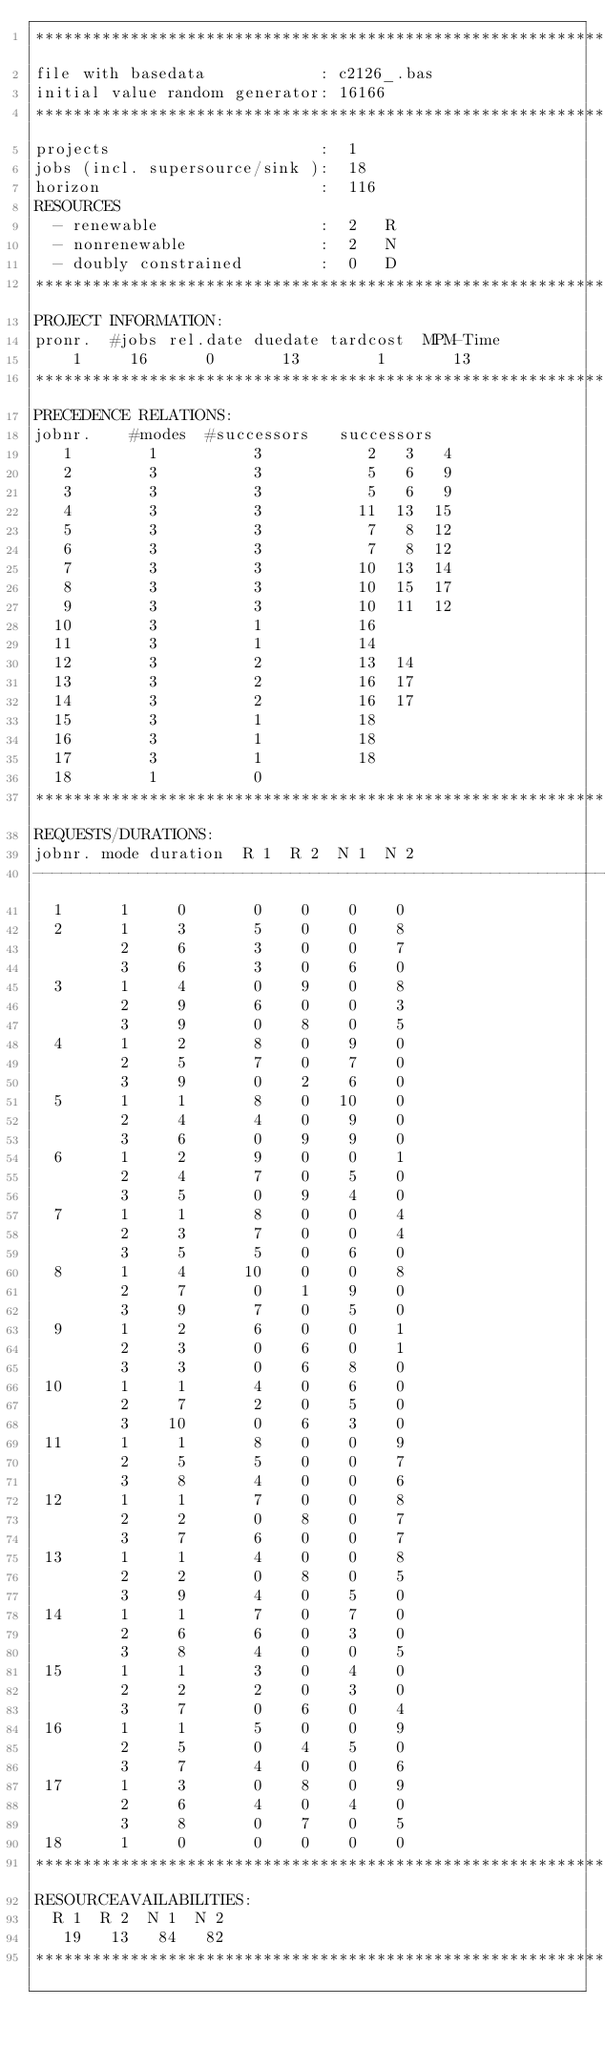Convert code to text. <code><loc_0><loc_0><loc_500><loc_500><_ObjectiveC_>************************************************************************
file with basedata            : c2126_.bas
initial value random generator: 16166
************************************************************************
projects                      :  1
jobs (incl. supersource/sink ):  18
horizon                       :  116
RESOURCES
  - renewable                 :  2   R
  - nonrenewable              :  2   N
  - doubly constrained        :  0   D
************************************************************************
PROJECT INFORMATION:
pronr.  #jobs rel.date duedate tardcost  MPM-Time
    1     16      0       13        1       13
************************************************************************
PRECEDENCE RELATIONS:
jobnr.    #modes  #successors   successors
   1        1          3           2   3   4
   2        3          3           5   6   9
   3        3          3           5   6   9
   4        3          3          11  13  15
   5        3          3           7   8  12
   6        3          3           7   8  12
   7        3          3          10  13  14
   8        3          3          10  15  17
   9        3          3          10  11  12
  10        3          1          16
  11        3          1          14
  12        3          2          13  14
  13        3          2          16  17
  14        3          2          16  17
  15        3          1          18
  16        3          1          18
  17        3          1          18
  18        1          0        
************************************************************************
REQUESTS/DURATIONS:
jobnr. mode duration  R 1  R 2  N 1  N 2
------------------------------------------------------------------------
  1      1     0       0    0    0    0
  2      1     3       5    0    0    8
         2     6       3    0    0    7
         3     6       3    0    6    0
  3      1     4       0    9    0    8
         2     9       6    0    0    3
         3     9       0    8    0    5
  4      1     2       8    0    9    0
         2     5       7    0    7    0
         3     9       0    2    6    0
  5      1     1       8    0   10    0
         2     4       4    0    9    0
         3     6       0    9    9    0
  6      1     2       9    0    0    1
         2     4       7    0    5    0
         3     5       0    9    4    0
  7      1     1       8    0    0    4
         2     3       7    0    0    4
         3     5       5    0    6    0
  8      1     4      10    0    0    8
         2     7       0    1    9    0
         3     9       7    0    5    0
  9      1     2       6    0    0    1
         2     3       0    6    0    1
         3     3       0    6    8    0
 10      1     1       4    0    6    0
         2     7       2    0    5    0
         3    10       0    6    3    0
 11      1     1       8    0    0    9
         2     5       5    0    0    7
         3     8       4    0    0    6
 12      1     1       7    0    0    8
         2     2       0    8    0    7
         3     7       6    0    0    7
 13      1     1       4    0    0    8
         2     2       0    8    0    5
         3     9       4    0    5    0
 14      1     1       7    0    7    0
         2     6       6    0    3    0
         3     8       4    0    0    5
 15      1     1       3    0    4    0
         2     2       2    0    3    0
         3     7       0    6    0    4
 16      1     1       5    0    0    9
         2     5       0    4    5    0
         3     7       4    0    0    6
 17      1     3       0    8    0    9
         2     6       4    0    4    0
         3     8       0    7    0    5
 18      1     0       0    0    0    0
************************************************************************
RESOURCEAVAILABILITIES:
  R 1  R 2  N 1  N 2
   19   13   84   82
************************************************************************
</code> 